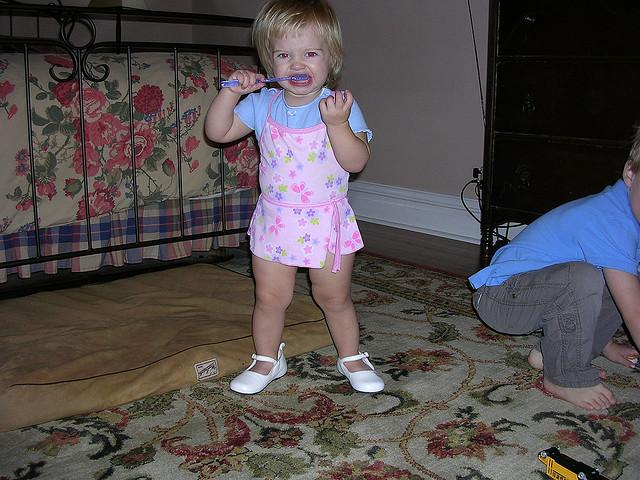Why are her eyes red?

Choices:
A) camera filter
B) reflected light
C) birth defect
D) contact lenses reflected light 